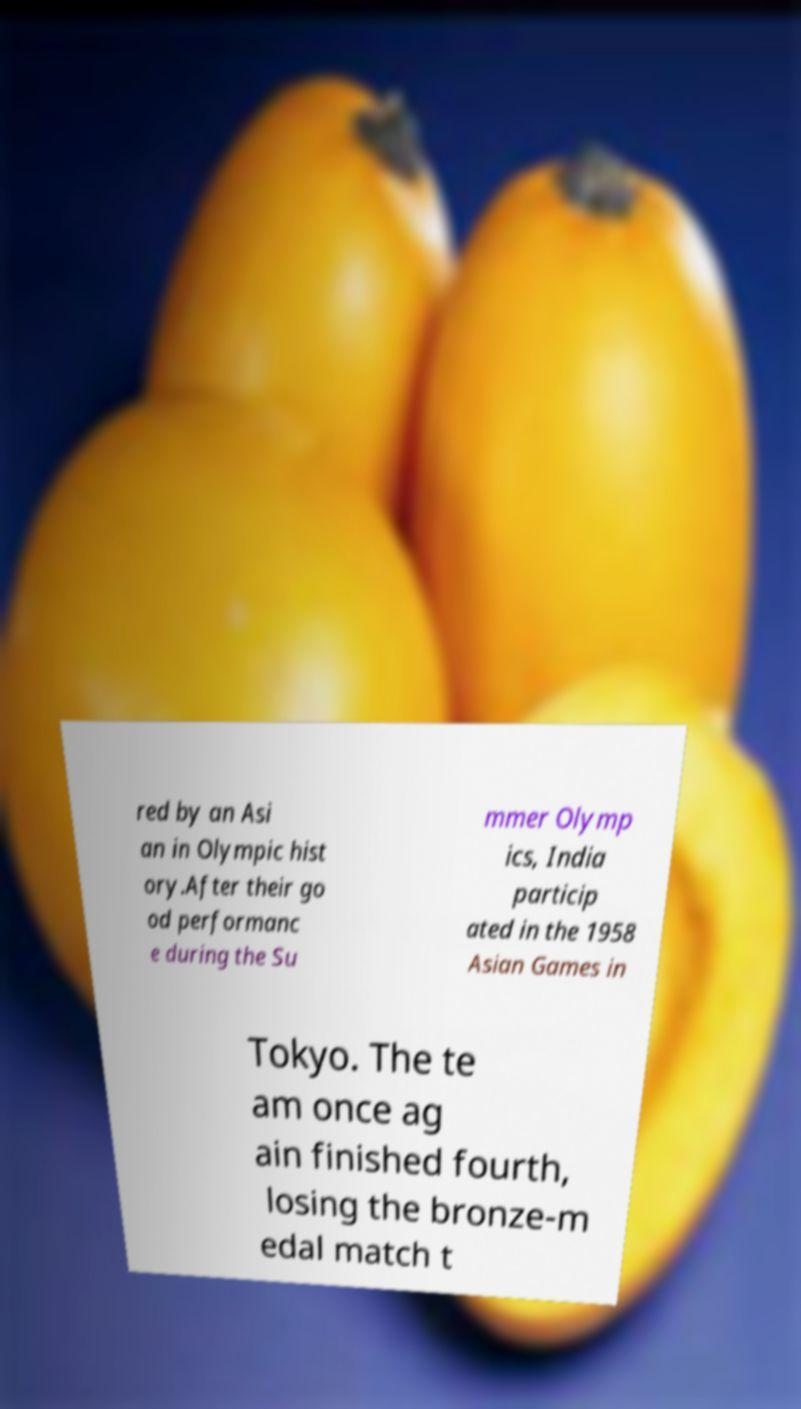What messages or text are displayed in this image? I need them in a readable, typed format. red by an Asi an in Olympic hist ory.After their go od performanc e during the Su mmer Olymp ics, India particip ated in the 1958 Asian Games in Tokyo. The te am once ag ain finished fourth, losing the bronze-m edal match t 